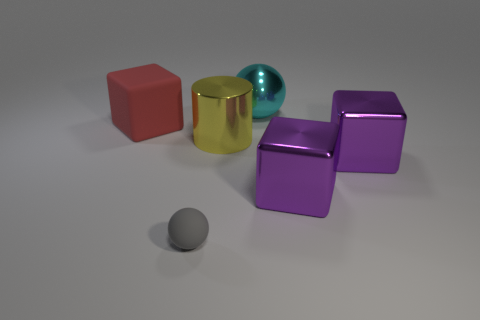What is the material of the large thing to the left of the gray sphere?
Ensure brevity in your answer.  Rubber. Is the color of the metallic thing that is behind the red cube the same as the ball in front of the large red thing?
Offer a terse response. No. What number of things are either big metal cylinders or metal cubes?
Your response must be concise. 3. How many other things are the same shape as the yellow metal thing?
Your response must be concise. 0. Does the cube that is left of the big ball have the same material as the ball that is on the left side of the cyan metallic object?
Ensure brevity in your answer.  Yes. What is the shape of the big thing that is to the left of the big ball and right of the red thing?
Ensure brevity in your answer.  Cylinder. Are there any other things that have the same material as the large cylinder?
Ensure brevity in your answer.  Yes. The object that is both left of the big metal cylinder and behind the tiny gray rubber thing is made of what material?
Offer a very short reply. Rubber. There is a big yellow object that is made of the same material as the big cyan ball; what is its shape?
Provide a short and direct response. Cylinder. Are there any other things that are the same color as the large rubber cube?
Ensure brevity in your answer.  No. 